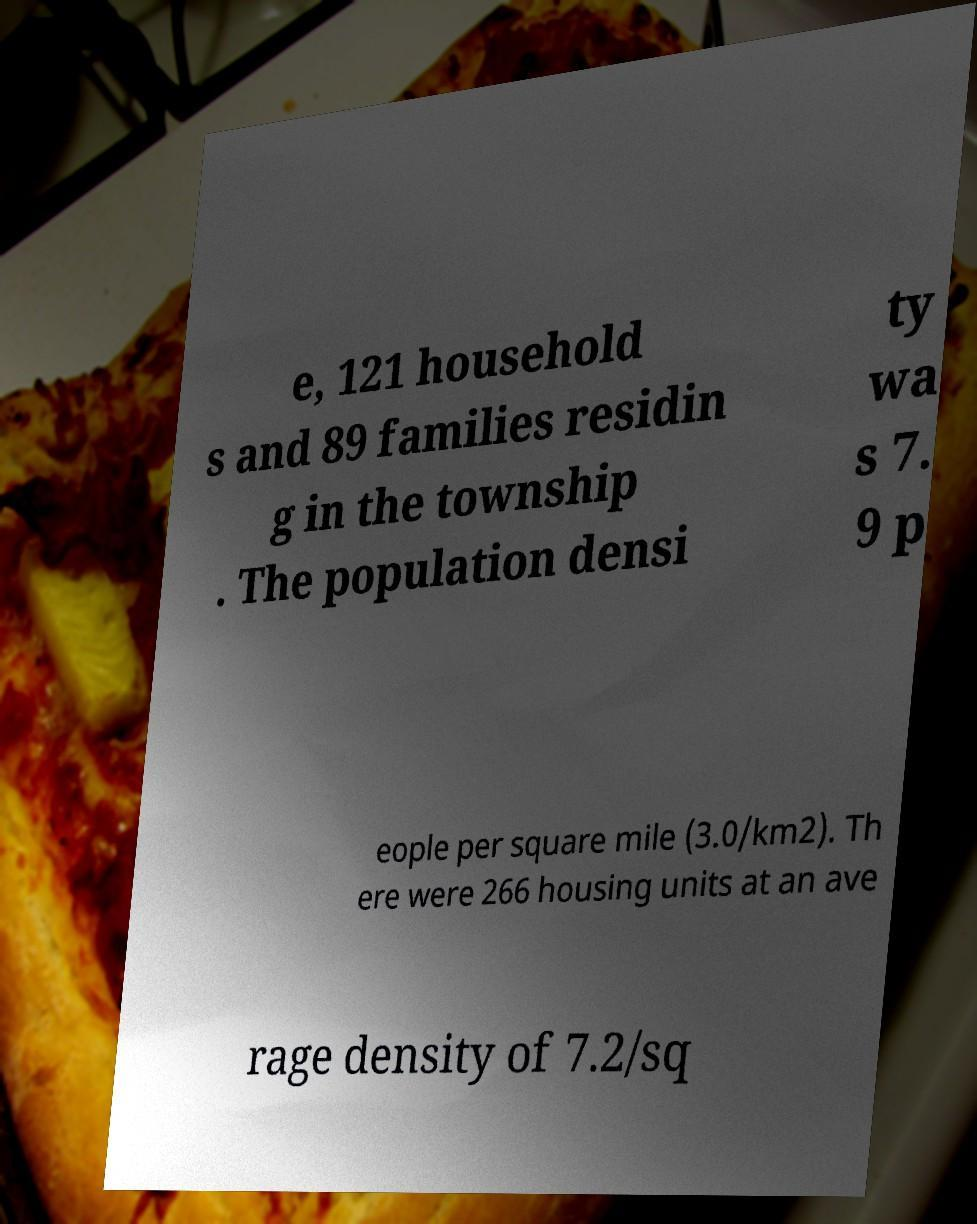Could you extract and type out the text from this image? e, 121 household s and 89 families residin g in the township . The population densi ty wa s 7. 9 p eople per square mile (3.0/km2). Th ere were 266 housing units at an ave rage density of 7.2/sq 